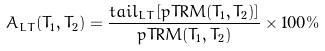<formula> <loc_0><loc_0><loc_500><loc_500>A _ { L T } ( T _ { 1 } , T _ { 2 } ) = \frac { t a i l _ { L T } [ p T R M ( T _ { 1 } , T _ { 2 } ) ] } { p T R M ( T _ { 1 } , T _ { 2 } ) } \times 1 0 0 \%</formula> 